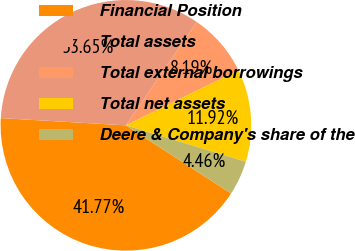Convert chart to OTSL. <chart><loc_0><loc_0><loc_500><loc_500><pie_chart><fcel>Financial Position<fcel>Total assets<fcel>Total external borrowings<fcel>Total net assets<fcel>Deere & Company's share of the<nl><fcel>41.77%<fcel>33.65%<fcel>8.19%<fcel>11.92%<fcel>4.46%<nl></chart> 